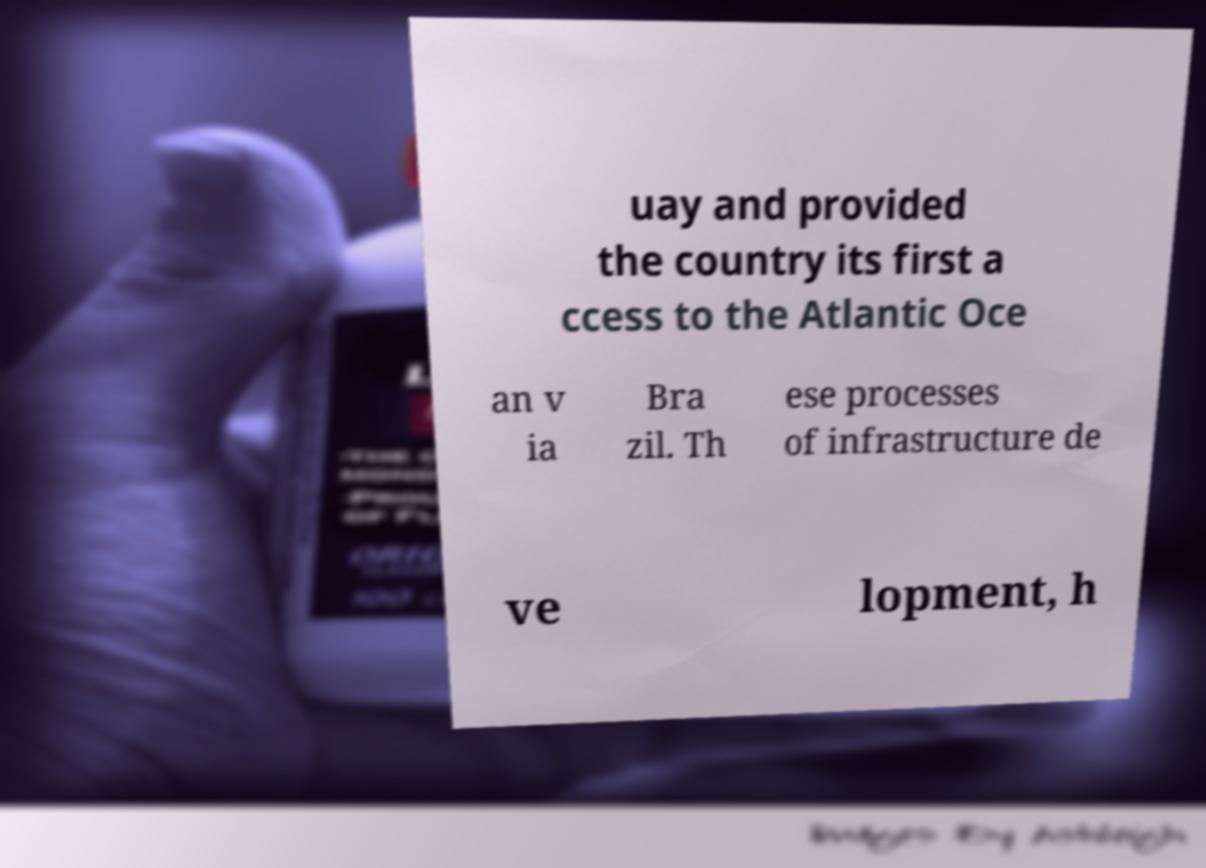I need the written content from this picture converted into text. Can you do that? uay and provided the country its first a ccess to the Atlantic Oce an v ia Bra zil. Th ese processes of infrastructure de ve lopment, h 